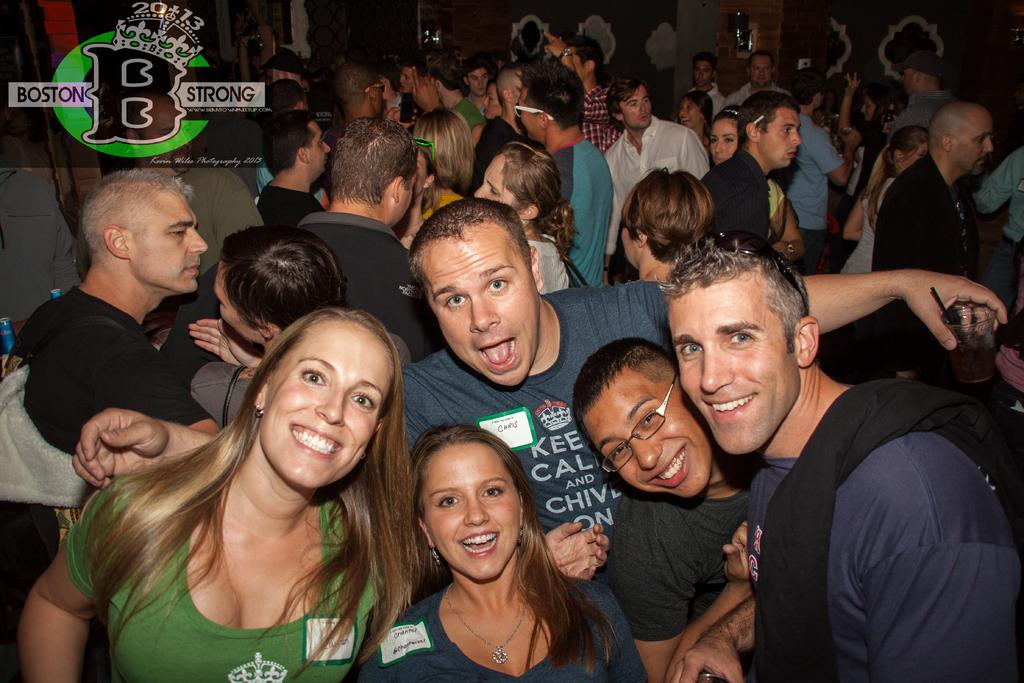What types of people are in the image? There are women and men in the image. How are the people in the image positioned? The people are standing together. What is the facial expression of the people in the image? The people are smiling. Can you describe the setting in the image? There are many people visible in the background of the image. What type of drug can be seen in the image? There is no drug present in the image. What kind of shoes are the people wearing in the image? The image does not show the shoes the people are wearing. 